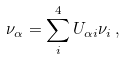<formula> <loc_0><loc_0><loc_500><loc_500>\nu _ { \alpha } = \sum _ { i } ^ { 4 } U _ { \alpha i } \nu _ { i } \, ,</formula> 